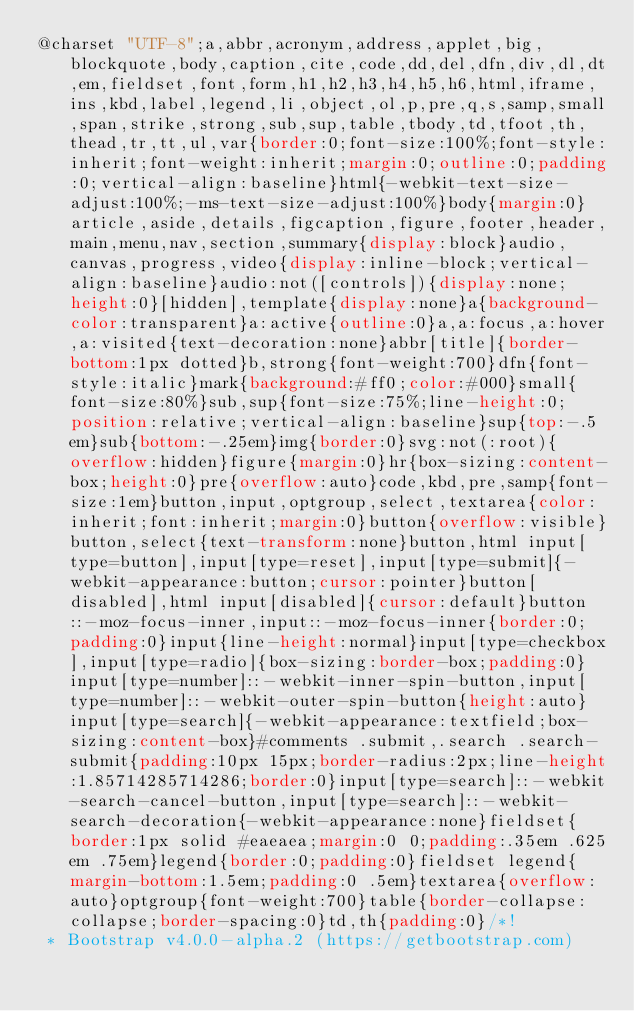<code> <loc_0><loc_0><loc_500><loc_500><_CSS_>@charset "UTF-8";a,abbr,acronym,address,applet,big,blockquote,body,caption,cite,code,dd,del,dfn,div,dl,dt,em,fieldset,font,form,h1,h2,h3,h4,h5,h6,html,iframe,ins,kbd,label,legend,li,object,ol,p,pre,q,s,samp,small,span,strike,strong,sub,sup,table,tbody,td,tfoot,th,thead,tr,tt,ul,var{border:0;font-size:100%;font-style:inherit;font-weight:inherit;margin:0;outline:0;padding:0;vertical-align:baseline}html{-webkit-text-size-adjust:100%;-ms-text-size-adjust:100%}body{margin:0}article,aside,details,figcaption,figure,footer,header,main,menu,nav,section,summary{display:block}audio,canvas,progress,video{display:inline-block;vertical-align:baseline}audio:not([controls]){display:none;height:0}[hidden],template{display:none}a{background-color:transparent}a:active{outline:0}a,a:focus,a:hover,a:visited{text-decoration:none}abbr[title]{border-bottom:1px dotted}b,strong{font-weight:700}dfn{font-style:italic}mark{background:#ff0;color:#000}small{font-size:80%}sub,sup{font-size:75%;line-height:0;position:relative;vertical-align:baseline}sup{top:-.5em}sub{bottom:-.25em}img{border:0}svg:not(:root){overflow:hidden}figure{margin:0}hr{box-sizing:content-box;height:0}pre{overflow:auto}code,kbd,pre,samp{font-size:1em}button,input,optgroup,select,textarea{color:inherit;font:inherit;margin:0}button{overflow:visible}button,select{text-transform:none}button,html input[type=button],input[type=reset],input[type=submit]{-webkit-appearance:button;cursor:pointer}button[disabled],html input[disabled]{cursor:default}button::-moz-focus-inner,input::-moz-focus-inner{border:0;padding:0}input{line-height:normal}input[type=checkbox],input[type=radio]{box-sizing:border-box;padding:0}input[type=number]::-webkit-inner-spin-button,input[type=number]::-webkit-outer-spin-button{height:auto}input[type=search]{-webkit-appearance:textfield;box-sizing:content-box}#comments .submit,.search .search-submit{padding:10px 15px;border-radius:2px;line-height:1.85714285714286;border:0}input[type=search]::-webkit-search-cancel-button,input[type=search]::-webkit-search-decoration{-webkit-appearance:none}fieldset{border:1px solid #eaeaea;margin:0 0;padding:.35em .625em .75em}legend{border:0;padding:0}fieldset legend{margin-bottom:1.5em;padding:0 .5em}textarea{overflow:auto}optgroup{font-weight:700}table{border-collapse:collapse;border-spacing:0}td,th{padding:0}/*!
 * Bootstrap v4.0.0-alpha.2 (https://getbootstrap.com)</code> 